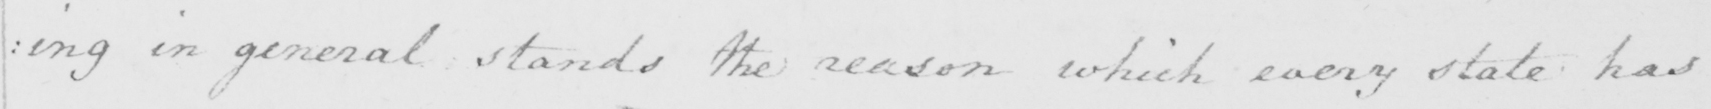Please transcribe the handwritten text in this image. : ing in general stands the reason which every state has 